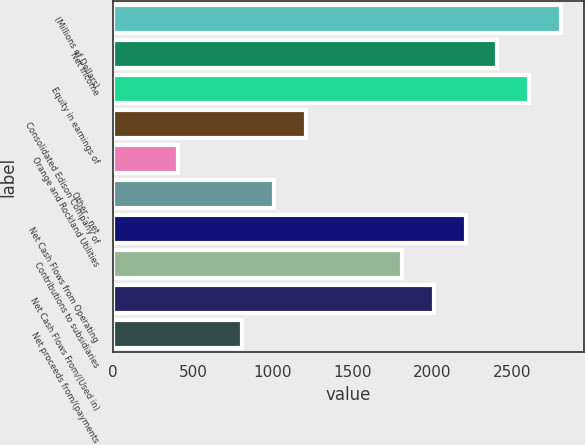Convert chart. <chart><loc_0><loc_0><loc_500><loc_500><bar_chart><fcel>(Millions of Dollars)<fcel>Net Income<fcel>Equity in earnings of<fcel>Consolidated Edison Company of<fcel>Orange and Rockland Utilities<fcel>Other - net<fcel>Net Cash Flows from Operating<fcel>Contributions to subsidiaries<fcel>Net Cash Flows From/(Used in)<fcel>Net proceeds from/(payments<nl><fcel>2806.2<fcel>2406.6<fcel>2606.4<fcel>1207.8<fcel>408.6<fcel>1008<fcel>2206.8<fcel>1807.2<fcel>2007<fcel>808.2<nl></chart> 